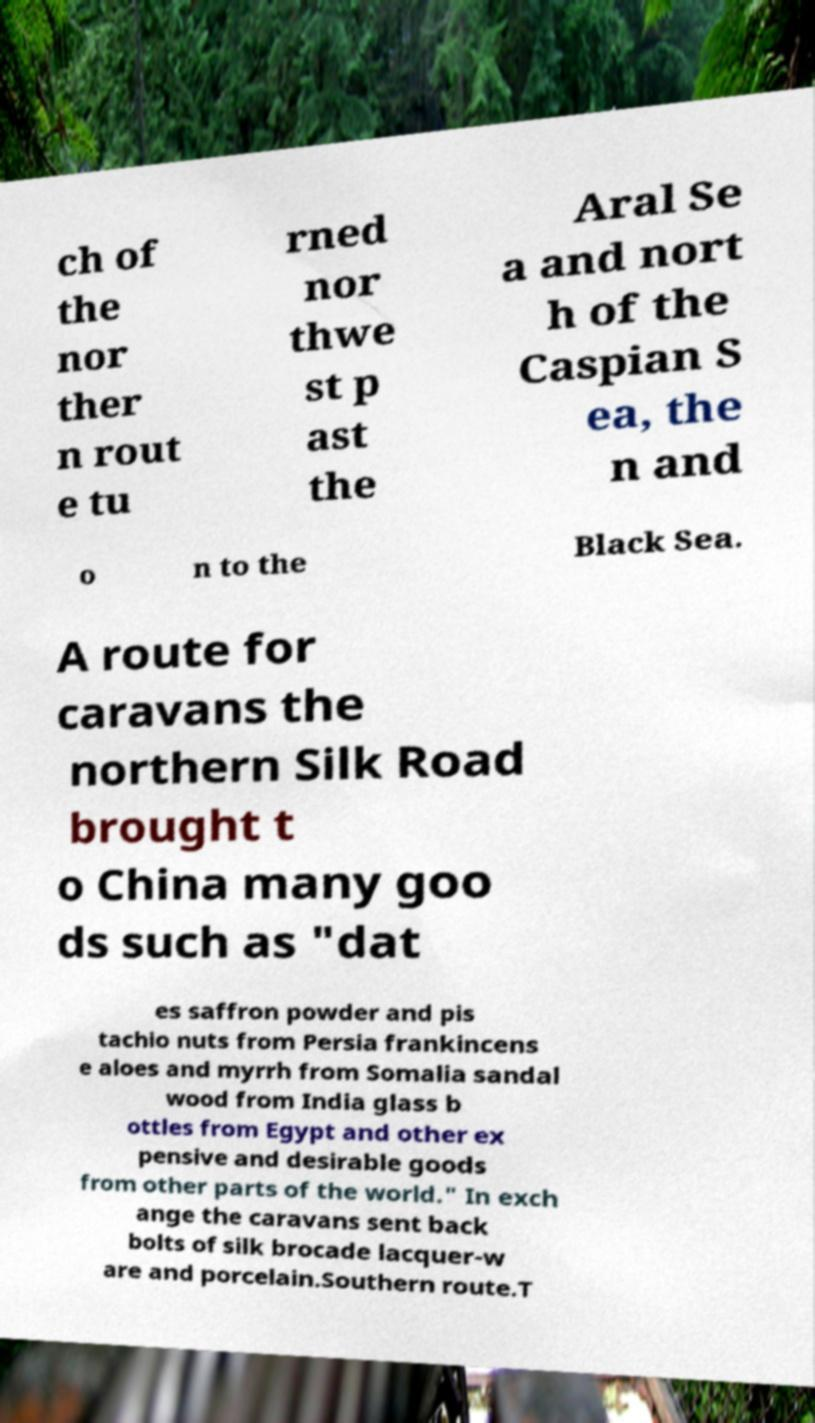What messages or text are displayed in this image? I need them in a readable, typed format. ch of the nor ther n rout e tu rned nor thwe st p ast the Aral Se a and nort h of the Caspian S ea, the n and o n to the Black Sea. A route for caravans the northern Silk Road brought t o China many goo ds such as "dat es saffron powder and pis tachio nuts from Persia frankincens e aloes and myrrh from Somalia sandal wood from India glass b ottles from Egypt and other ex pensive and desirable goods from other parts of the world." In exch ange the caravans sent back bolts of silk brocade lacquer-w are and porcelain.Southern route.T 